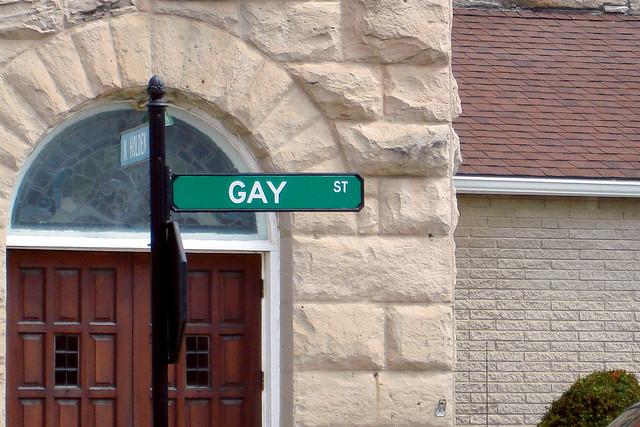What street does this sign say?
Answer briefly. Gay. What are the doors made of?
Quick response, please. Wood. What is the building behind the sign?
Quick response, please. Church. 